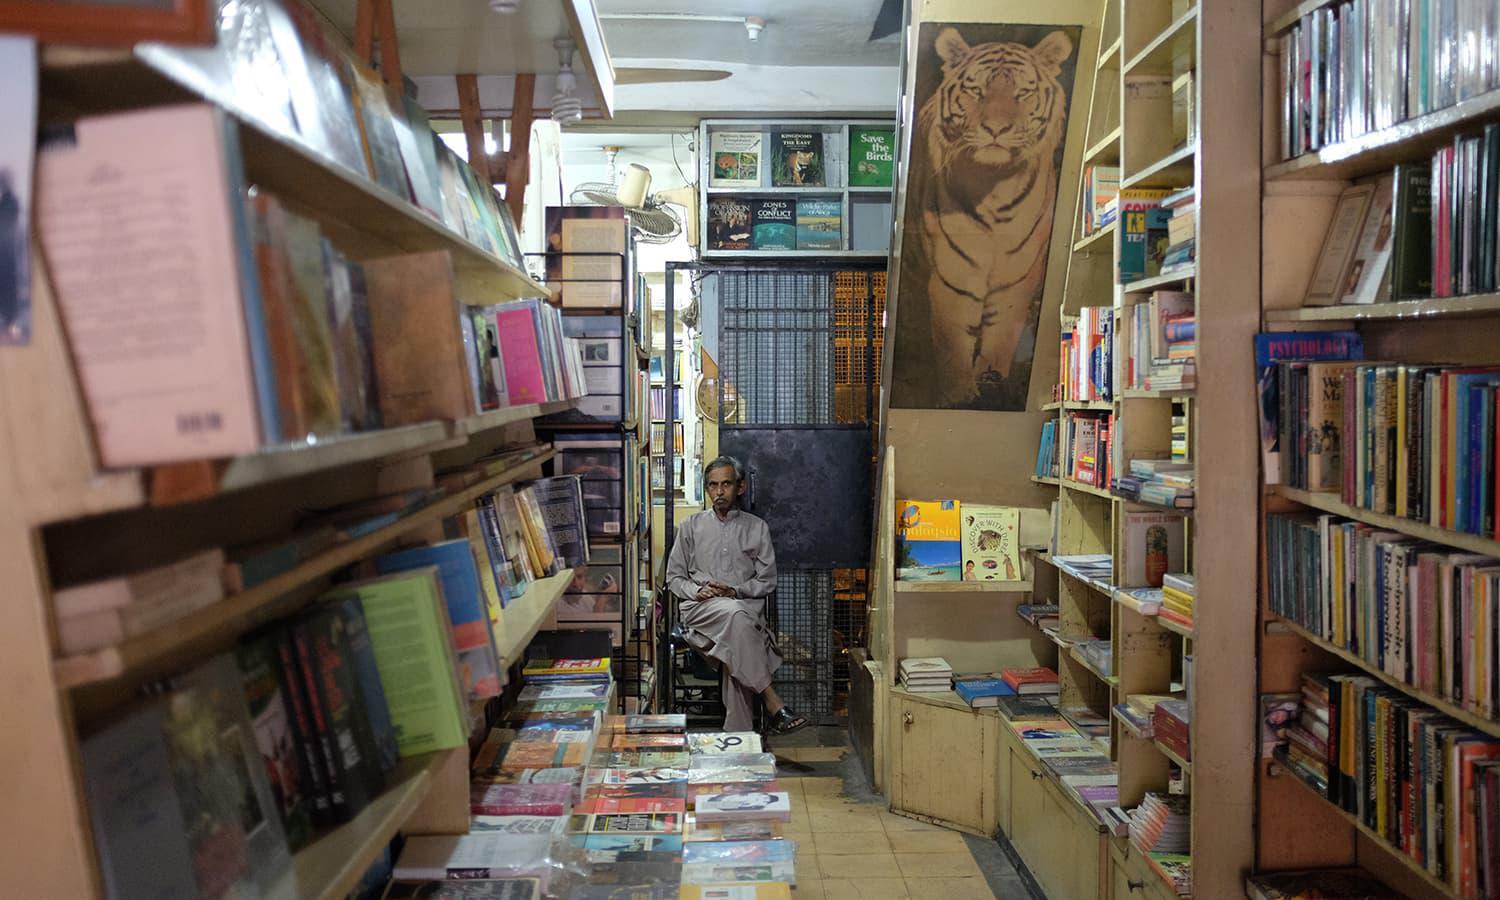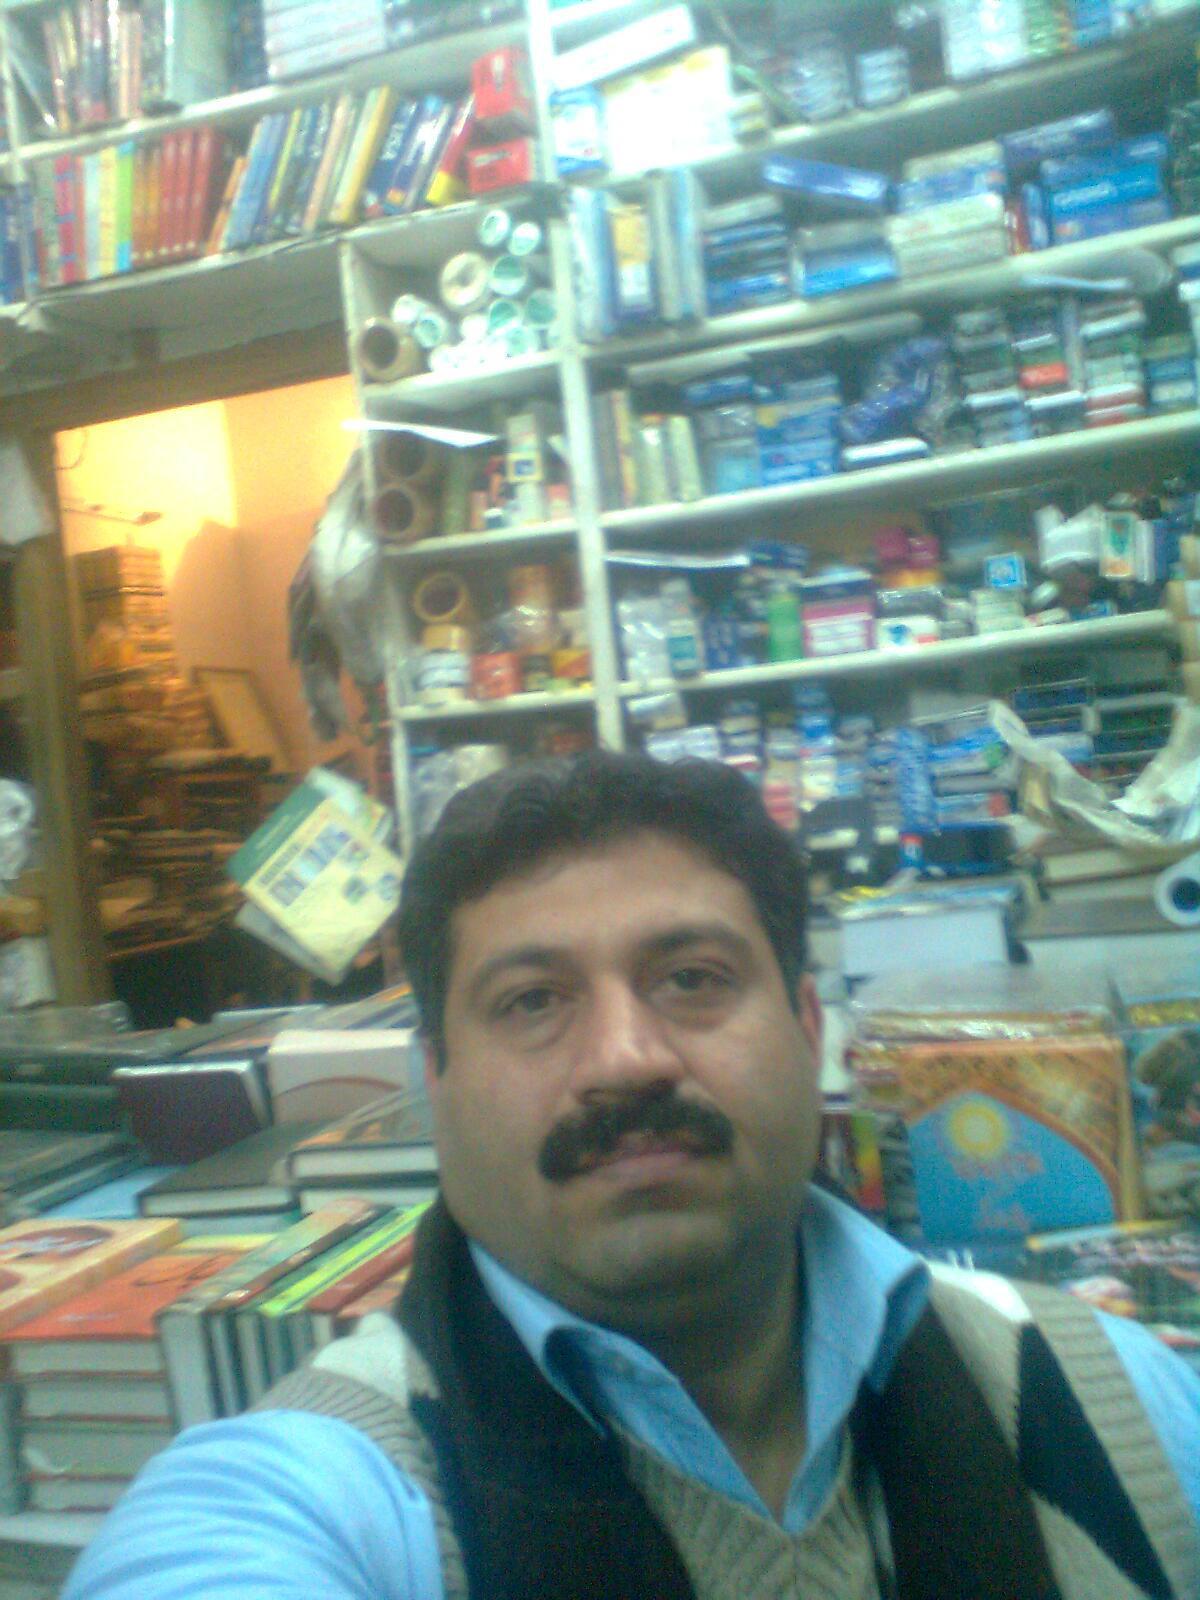The first image is the image on the left, the second image is the image on the right. For the images displayed, is the sentence "There are products on the asphalt road in both images." factually correct? Answer yes or no. No. The first image is the image on the left, the second image is the image on the right. Considering the images on both sides, is "One woman is wearing a hijab while shopping for books." valid? Answer yes or no. No. 